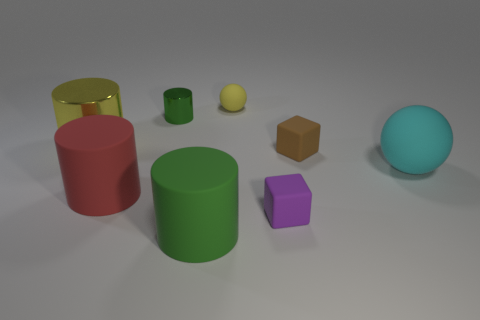Are there any yellow cylinders?
Make the answer very short. Yes. There is a ball behind the rubber sphere that is in front of the yellow thing that is behind the large metallic cylinder; what is its material?
Your answer should be compact. Rubber. Does the brown matte thing have the same shape as the tiny object left of the yellow ball?
Offer a very short reply. No. How many big cyan objects have the same shape as the red thing?
Keep it short and to the point. 0. The red matte object is what shape?
Make the answer very short. Cylinder. What size is the green object that is on the left side of the large matte cylinder that is in front of the big red matte object?
Offer a very short reply. Small. How many objects are big red things or brown things?
Offer a terse response. 2. Does the purple object have the same shape as the large cyan matte thing?
Offer a very short reply. No. Are there any brown things that have the same material as the red cylinder?
Give a very brief answer. Yes. Is there a red thing on the left side of the rubber sphere that is in front of the tiny green metallic cylinder?
Your response must be concise. Yes. 